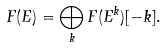<formula> <loc_0><loc_0><loc_500><loc_500>F ( E ) = \bigoplus _ { k } F ( E ^ { k } ) [ - k ] .</formula> 